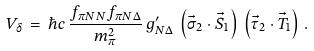<formula> <loc_0><loc_0><loc_500><loc_500>V _ { \delta } \, = \, \hbar { c } \, \frac { f _ { \pi N N } f _ { \pi N \Delta } } { m ^ { 2 } _ { \pi } } \, g ^ { \prime } _ { N \Delta } \, \left ( \vec { \sigma } _ { 2 } \cdot \vec { S } _ { 1 } \right ) \, \left ( \vec { \tau } _ { 2 } \cdot \vec { T } _ { 1 } \right ) \, .</formula> 